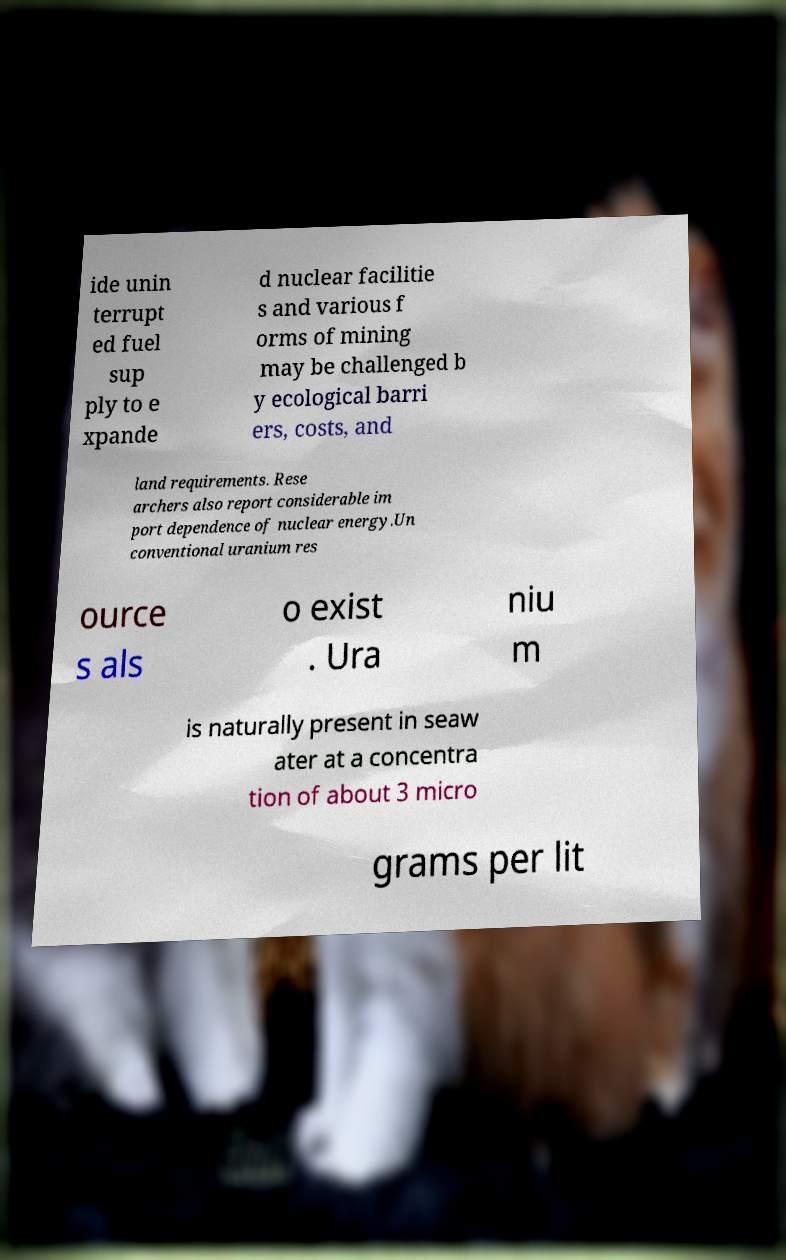For documentation purposes, I need the text within this image transcribed. Could you provide that? ide unin terrupt ed fuel sup ply to e xpande d nuclear facilitie s and various f orms of mining may be challenged b y ecological barri ers, costs, and land requirements. Rese archers also report considerable im port dependence of nuclear energy.Un conventional uranium res ource s als o exist . Ura niu m is naturally present in seaw ater at a concentra tion of about 3 micro grams per lit 